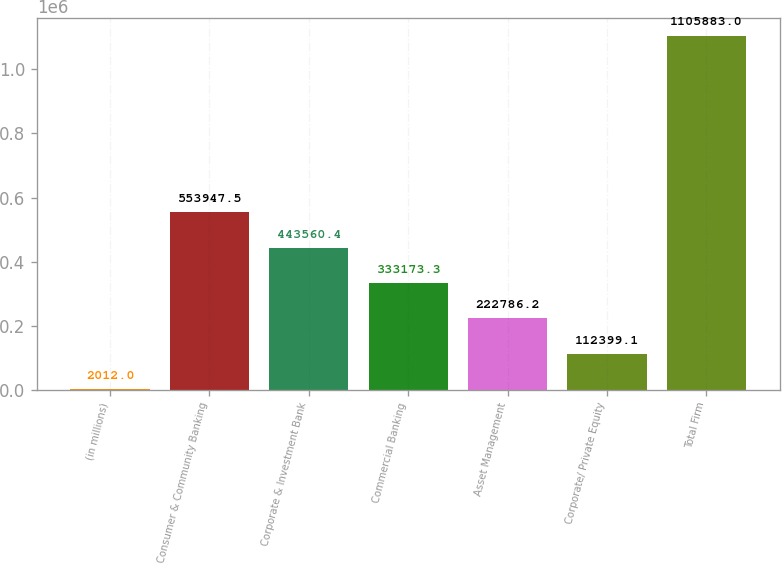<chart> <loc_0><loc_0><loc_500><loc_500><bar_chart><fcel>(in millions)<fcel>Consumer & Community Banking<fcel>Corporate & Investment Bank<fcel>Commercial Banking<fcel>Asset Management<fcel>Corporate/ Private Equity<fcel>Total Firm<nl><fcel>2012<fcel>553948<fcel>443560<fcel>333173<fcel>222786<fcel>112399<fcel>1.10588e+06<nl></chart> 